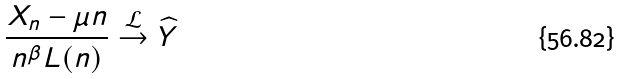Convert formula to latex. <formula><loc_0><loc_0><loc_500><loc_500>\frac { X _ { n } - \mu n } { n ^ { \beta } L ( n ) } \stackrel { \mathcal { L } } { \to } \widehat { Y }</formula> 